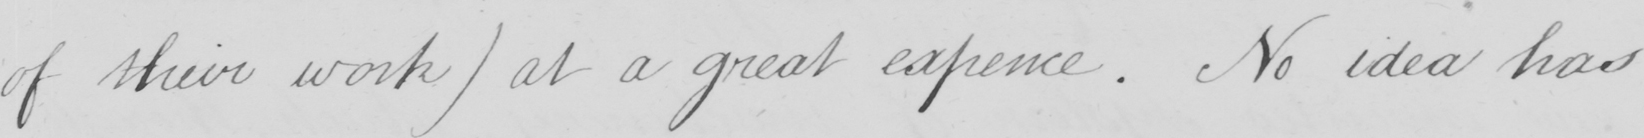Please provide the text content of this handwritten line. of their work )  at a great expence . No idea has 